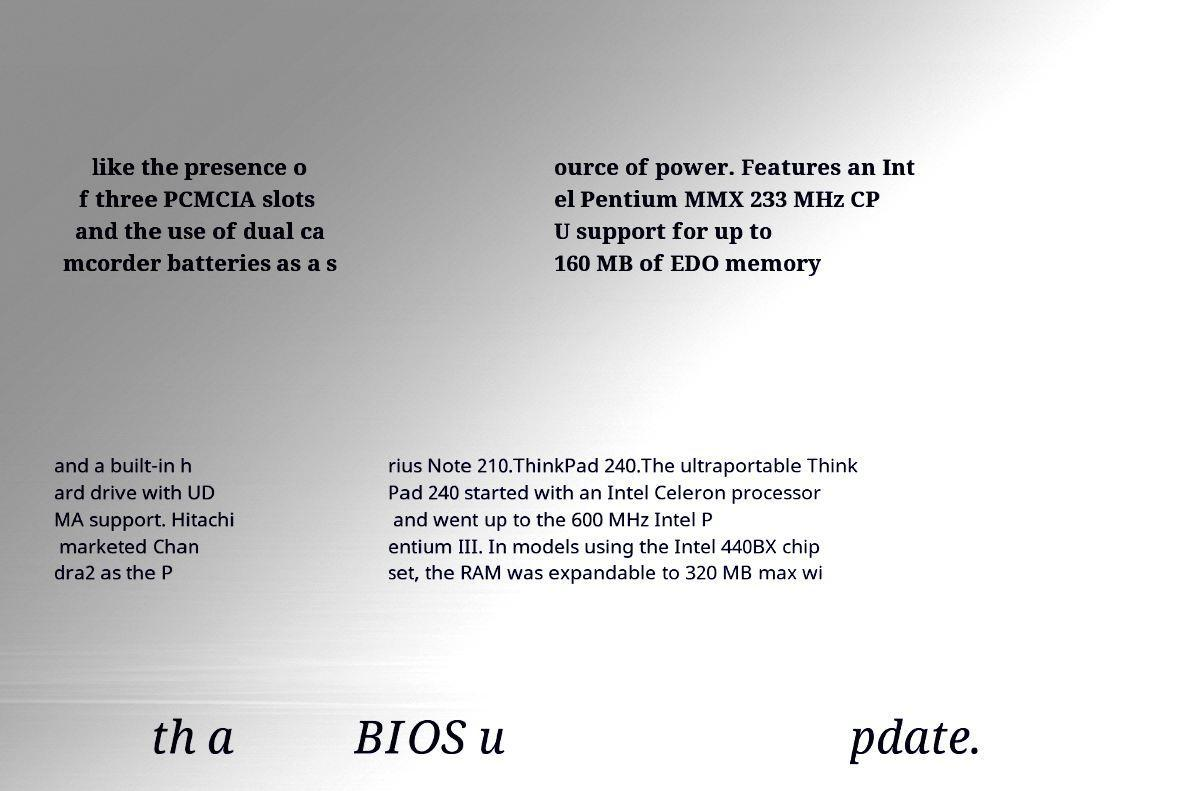Can you read and provide the text displayed in the image?This photo seems to have some interesting text. Can you extract and type it out for me? like the presence o f three PCMCIA slots and the use of dual ca mcorder batteries as a s ource of power. Features an Int el Pentium MMX 233 MHz CP U support for up to 160 MB of EDO memory and a built-in h ard drive with UD MA support. Hitachi marketed Chan dra2 as the P rius Note 210.ThinkPad 240.The ultraportable Think Pad 240 started with an Intel Celeron processor and went up to the 600 MHz Intel P entium III. In models using the Intel 440BX chip set, the RAM was expandable to 320 MB max wi th a BIOS u pdate. 